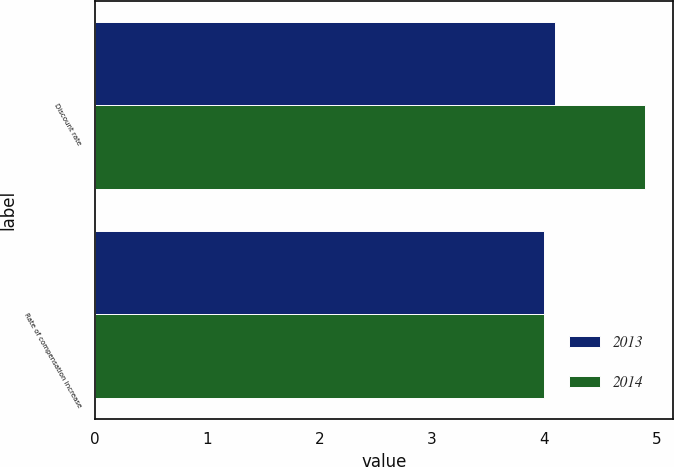Convert chart. <chart><loc_0><loc_0><loc_500><loc_500><stacked_bar_chart><ecel><fcel>Discount rate<fcel>Rate of compensation increase<nl><fcel>2013<fcel>4.1<fcel>4<nl><fcel>2014<fcel>4.9<fcel>4<nl></chart> 